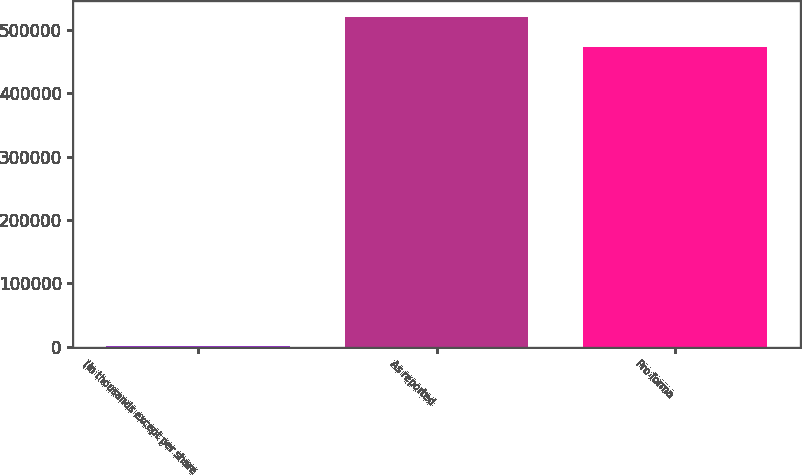<chart> <loc_0><loc_0><loc_500><loc_500><bar_chart><fcel>(in thousands except per share<fcel>As reported<fcel>Pro forma<nl><fcel>2004<fcel>519940<fcel>472653<nl></chart> 